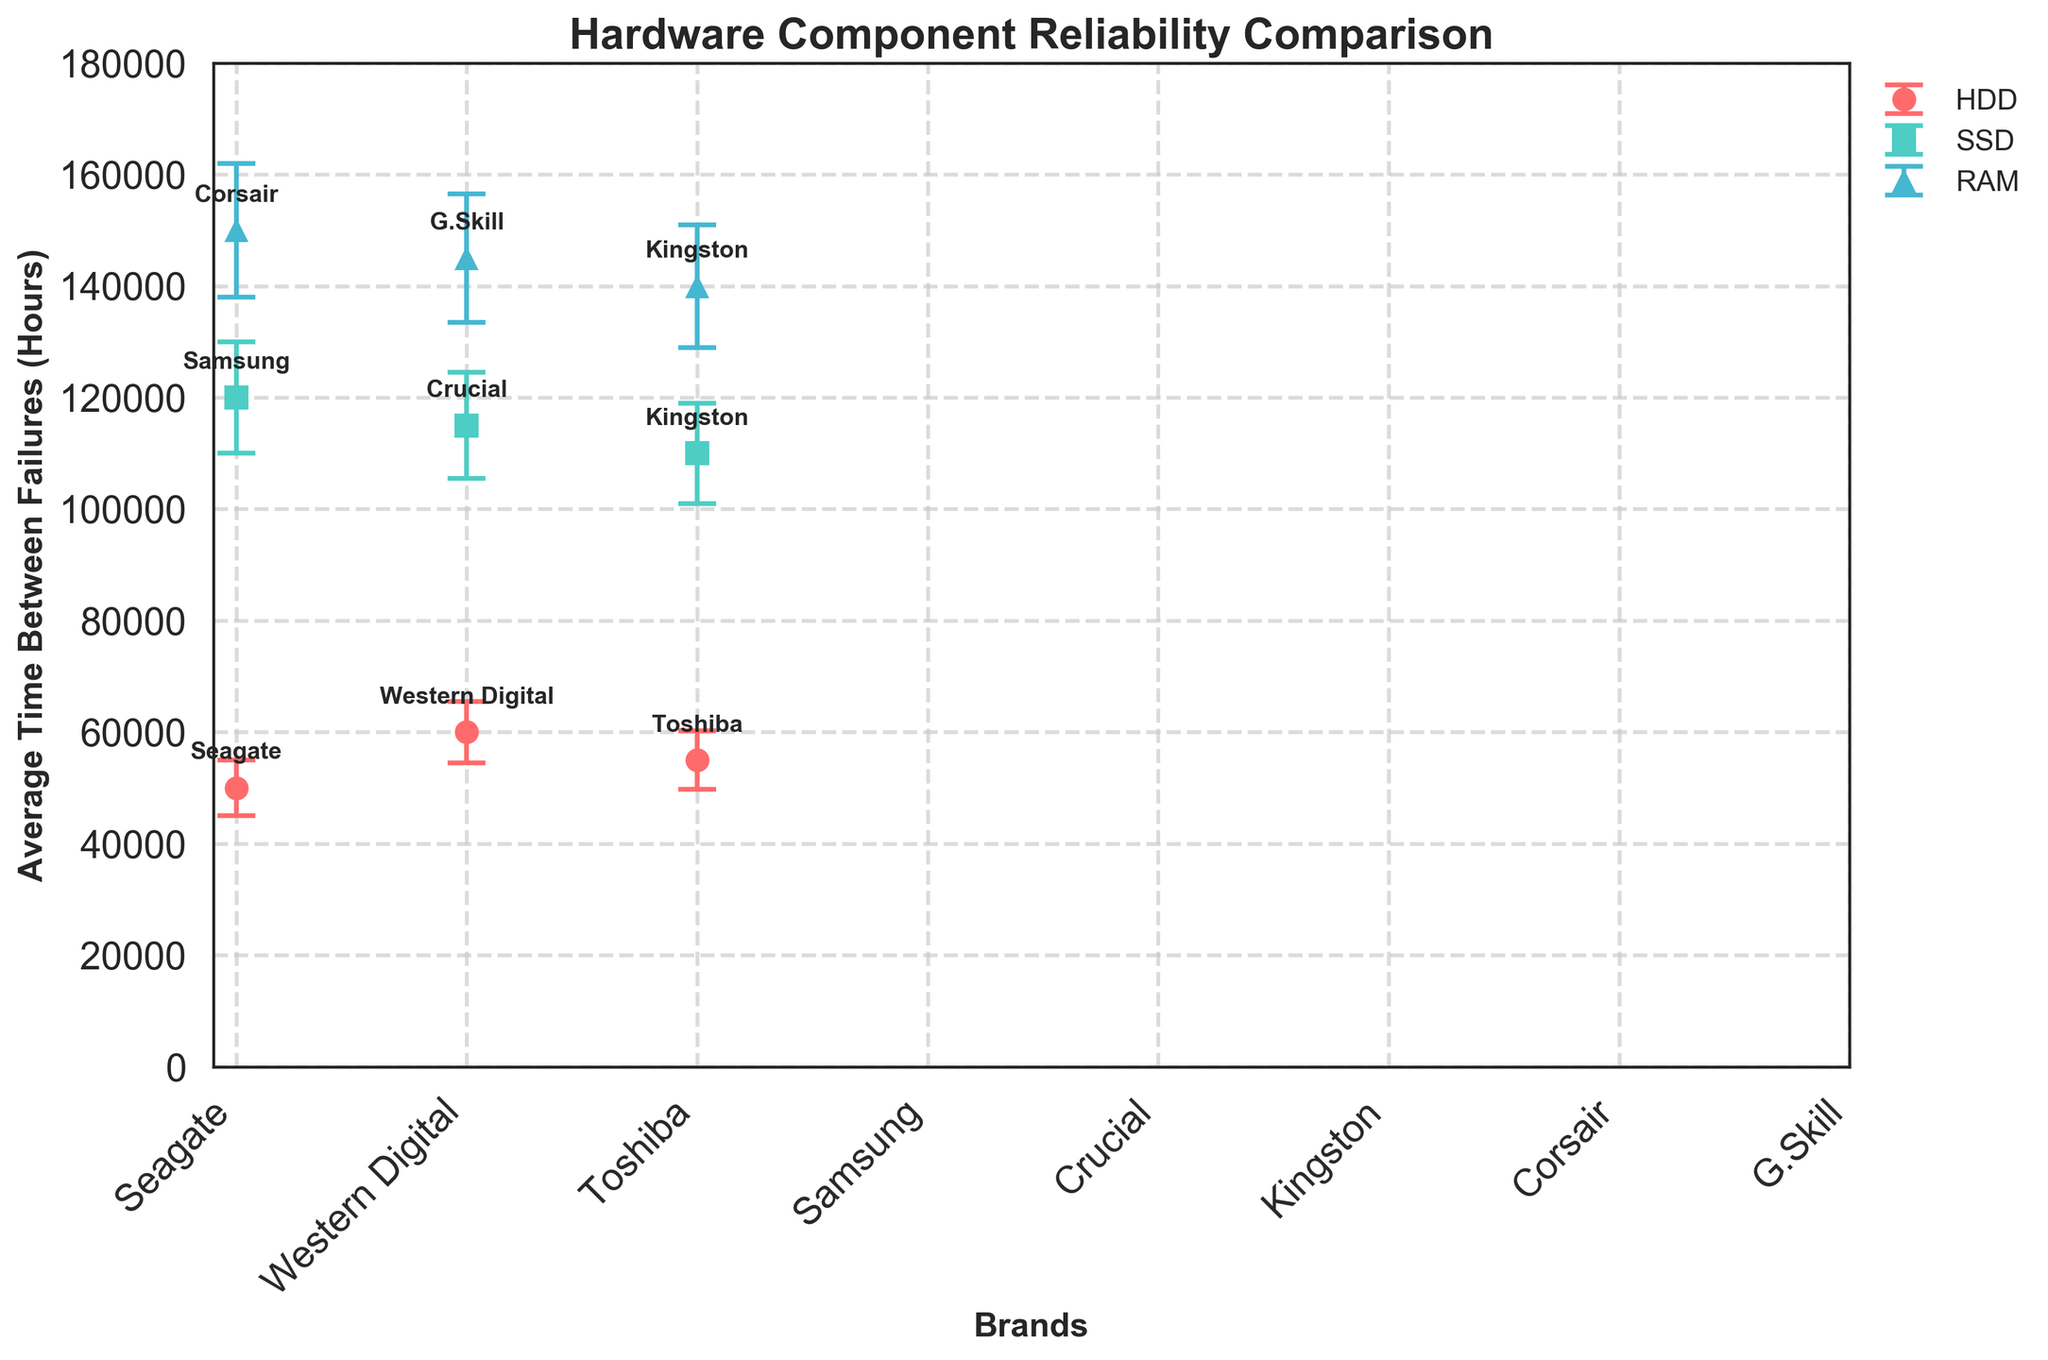What's the title of the plot? The title of the plot is displayed prominently at the top and describes the main subject of the figure.
Answer: Hardware Component Reliability Comparison What is the average time between failures for Samsung SSDs? Locate the Samsung SSD data point in the SSD group within the plot. The y-axis value for this point represents the average time between failures.
Answer: 120,000 hours Which RAM brand has the highest average time between failures? Among the RAM brands, compare the y-axis values of Corsair, G.Skill, and Kingston to determine which one is the highest.
Answer: Corsair How much higher is the average time between failures for Western Digital HDDs compared to Seagate HDDs? Find the y-axis values for Western Digital and Seagate HDDs, then subtract the value for Seagate from the value for Western Digital.
Answer: 10,000 hours What are the error margins for the Crucial SSDs? Look at the error bars on the Crucial SSD data point. The length of the error bar represents the error margin.
Answer: 9,500 hours Which component type (HDD, SSD, or RAM) has the highest average reliability? By comparing the highest average value within each component type (HDD, SSD, RAM), identify which one has the greatest y-axis value.
Answer: RAM What is the difference in the average time between failures between the highest and lowest brands for HDDs? Identify the highest and lowest y-axis values for HDD brands (Western Digital and Seagate) and calculate the difference.
Answer: 10,000 hours Do SSDs generally have higher reliability than HDDs based on the average time between failures? Compare the range of y-axis values for SSDs and HDDs to see if SSDs' average values are generally higher.
Answer: Yes What is the error margin range for RAM components? Identify the minimum and maximum error margins for Corsair, G.Skill, and Kingston RAM, then determine the range.
Answer: 11,000 to 12,000 hours How does the average reliability of G.Skill RAM compare to Kingston RAM? Compare the y-axis values of G.Skill and Kingston RAM data points to see which is higher.
Answer: G.Skill is higher 